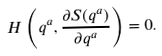Convert formula to latex. <formula><loc_0><loc_0><loc_500><loc_500>H \left ( q ^ { a } , \frac { \partial S ( q ^ { a } ) } { \partial q ^ { a } } \right ) = 0 .</formula> 